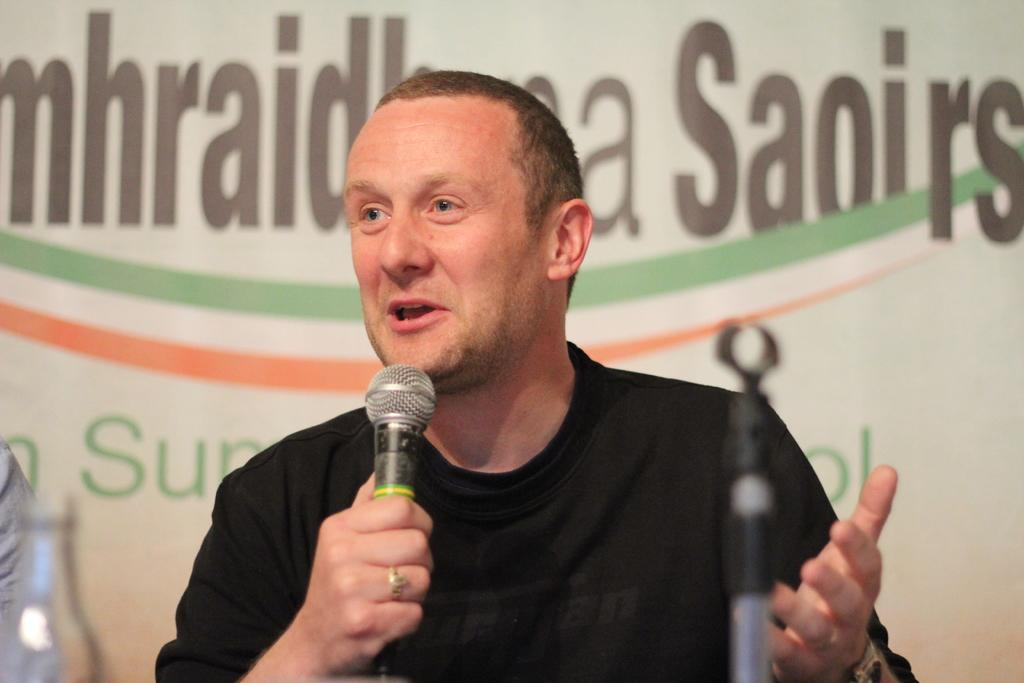What can be seen in the background of the image? There is a hoarding in the background of the image. Who is present in the image? There is a man in the image. What is the man wearing? The man is wearing a black t-shirt. What is the man holding in his hand? The man is holding a microphone in his hand. What other object related to the microphone can be seen in the image? There is a microphone stand in the image. What other item is visible in the image? There is a bottle in the image. What type of orange is being used as a stamp in the image? There is no orange or stamp present in the image. In which direction is the man facing in the image? The direction the man is facing cannot be determined from the image alone, as there is no reference point provided. 